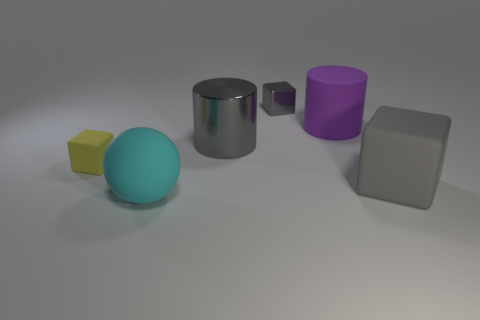If I were to categorize these objects by material, which categories would they fall into? Based on their appearance, the objects could be categorized as follows: the cube on the far left appears to be plastic; the large ball, with its matte surface, could be made of rubber; the metal cylinder has a reflective surface indicative of metal; the smaller cube seems to be plastic as well; and the square block, with its non-reflective surface, resembles a matte-finished stone or similar material. 